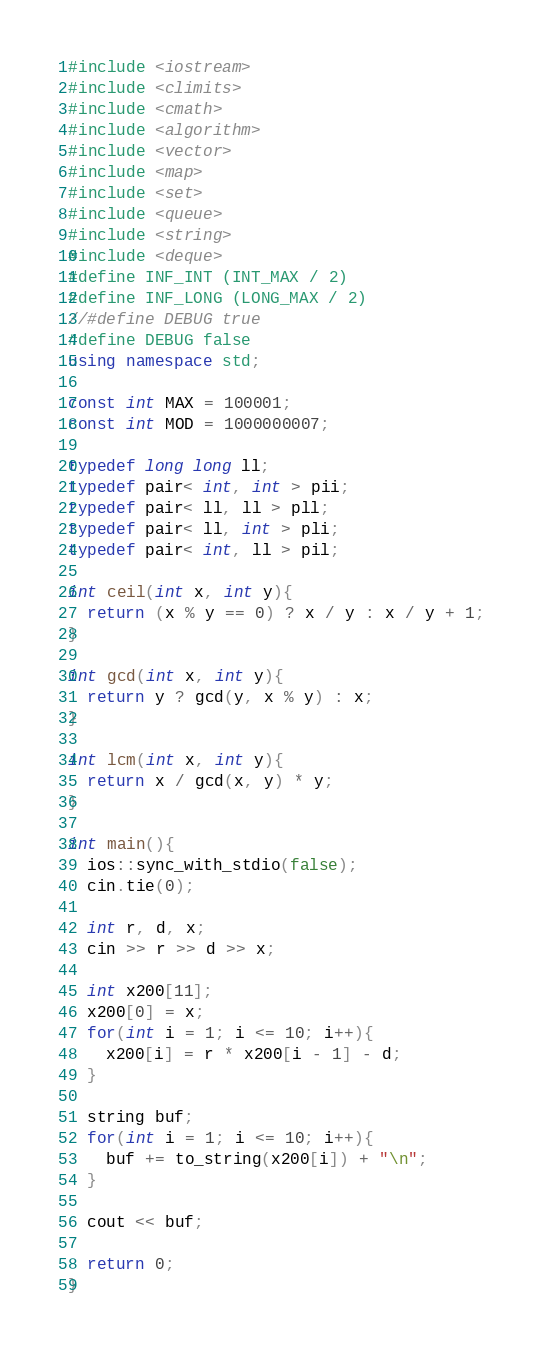Convert code to text. <code><loc_0><loc_0><loc_500><loc_500><_C++_>#include <iostream>
#include <climits>
#include <cmath>
#include <algorithm>
#include <vector>
#include <map>
#include <set>
#include <queue>
#include <string>
#include <deque>
#define INF_INT (INT_MAX / 2)
#define INF_LONG (LONG_MAX / 2)
//#define DEBUG true
#define DEBUG false
using namespace std;

const int MAX = 100001;
const int MOD = 1000000007;

typedef long long ll;
typedef pair< int, int > pii;
typedef pair< ll, ll > pll;
typedef pair< ll, int > pli;
typedef pair< int, ll > pil;

int ceil(int x, int y){
  return (x % y == 0) ? x / y : x / y + 1;
}

int gcd(int x, int y){
  return y ? gcd(y, x % y) : x;
}

int lcm(int x, int y){
  return x / gcd(x, y) * y;
}

int main(){
  ios::sync_with_stdio(false);
  cin.tie(0);

  int r, d, x;
  cin >> r >> d >> x;

  int x200[11];
  x200[0] = x;
  for(int i = 1; i <= 10; i++){
    x200[i] = r * x200[i - 1] - d;
  }

  string buf;
  for(int i = 1; i <= 10; i++){
    buf += to_string(x200[i]) + "\n";
  }

  cout << buf;

  return 0;
}
</code> 